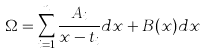Convert formula to latex. <formula><loc_0><loc_0><loc_500><loc_500>\Omega = \sum _ { i = 1 } ^ { n } \frac { A _ { i } } { x - t _ { i } } d x + B ( x ) d x</formula> 